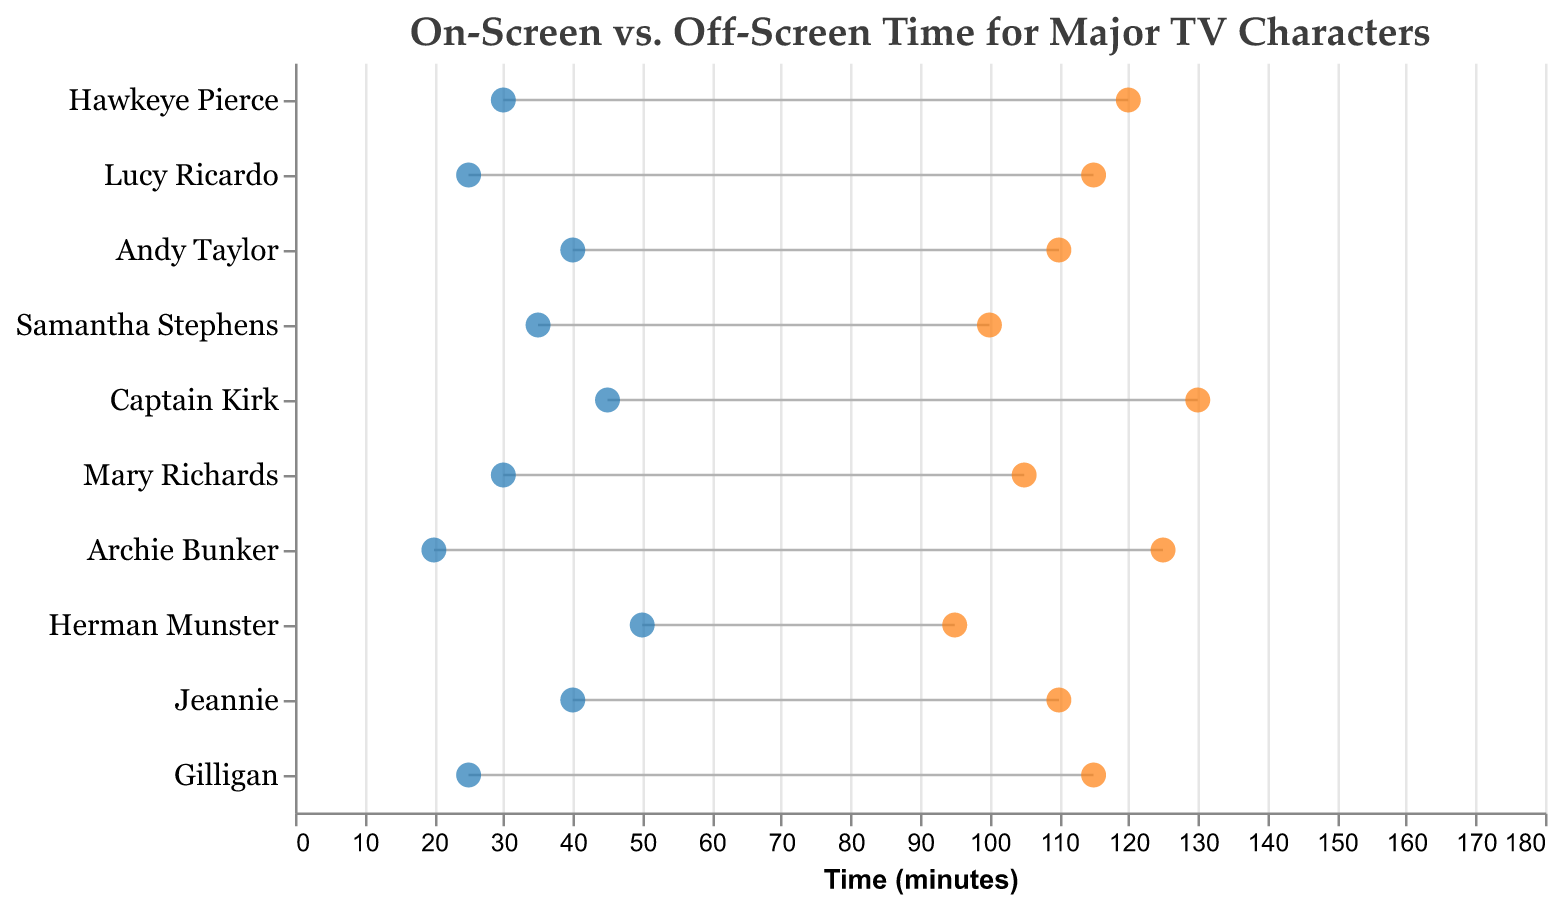What is the title of the figure? The title is located at the top of the figure and it reads "On-Screen vs. Off-Screen Time for Major TV Characters".
Answer: On-Screen vs. Off-Screen Time for Major TV Characters Which character has the longest on-screen time? By examining the data points, the character with the longest on-screen time is Captain Kirk, as indicated by the highest on-screen point on the x-axis.
Answer: Captain Kirk How many minutes is Hawkeye Pierce on screen? Looking at the blue dot for Hawkeye Pierce, the on-screen time is listed directly on the x-axis.
Answer: 120 What is the range of on-screen times for Herman Munster? The on-screen time range is represented by the length from the off-screen point to the on-screen point for Herman Munster. By subtracting off-screen time (50) from on-screen time (95), the range is 95-50.
Answer: 45 Which character has the greatest difference between on-screen and off-screen times? To find the greatest difference, we calculate the difference for each character and compare. Captain Kirk has the largest difference (130 on-screen time - 45 off-screen time).
Answer: Captain Kirk What is the total screen time (on-screen + off-screen) for Samantha Stephens? The total screen time is the sum of on-screen and off-screen times for Samantha Stephens, which is 100 + 35.
Answer: 135 Who has more off-screen time: Andy Taylor or Jeannie? By comparing the positions of the orange dots on the horizontal axis, we see Andy Taylor has the same off-screen time as Jeannie, both at 40 minutes.
Answer: They have the same off-screen time What are the on-screen times for the characters from "I Love Lucy" and "Gilligan's Island"? Are they the same? Both characters from "I Love Lucy" (Lucy Ricardo) and "Gilligan's Island" (Gilligan) have their on-screen times listed at 115.
Answer: Yes How does Archie Bunker's off-screen time compare to Lucy Ricardo's off-screen time? By looking at the orange dots corresponding to Archie Bunker and Lucy Ricardo, we see that Archie's off-screen time is less (20) compared to Lucy Ricardo’s (25).
Answer: Less What is the average on-screen time for all the characters? To find the average, sum up the on-screen times for all characters and divide by the number of characters: (120 + 115 + 110 + 100 + 130 + 105 + 125 + 95 + 110 + 115)/10. Thus, (1125/10) equals 112.5.
Answer: 112.5 